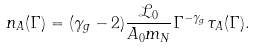<formula> <loc_0><loc_0><loc_500><loc_500>n _ { A } ( \Gamma ) = ( \gamma _ { g } - 2 ) \frac { \mathcal { L } _ { 0 } } { A _ { 0 } m _ { N } } \Gamma ^ { - \gamma _ { g } } \tau _ { A } ( \Gamma ) .</formula> 